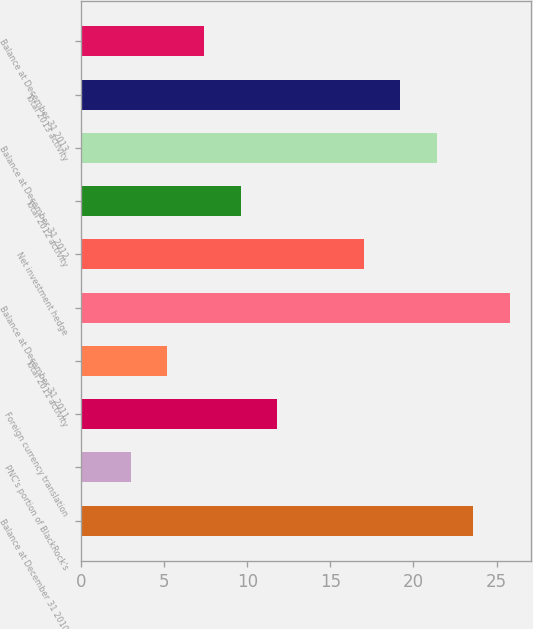Convert chart to OTSL. <chart><loc_0><loc_0><loc_500><loc_500><bar_chart><fcel>Balance at December 31 2010<fcel>PNC's portion of BlackRock's<fcel>Foreign currency translation<fcel>Total 2011 activity<fcel>Balance at December 31 2011<fcel>Net investment hedge<fcel>Total 2012 activity<fcel>Balance at December 31 2012<fcel>Total 2013 activity<fcel>Balance at December 31 2013<nl><fcel>23.6<fcel>3<fcel>11.8<fcel>5.2<fcel>25.8<fcel>17<fcel>9.6<fcel>21.4<fcel>19.2<fcel>7.4<nl></chart> 